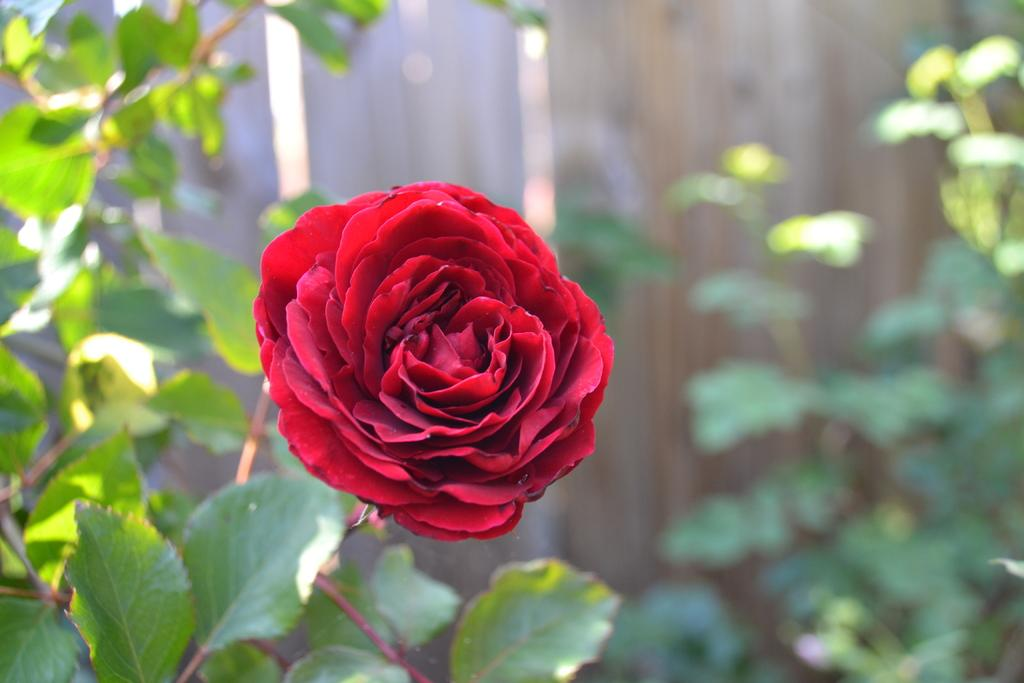What type of living organism can be seen in the image? There is a flower in the image. Are there any other plants visible in the image? Yes, there are plants in the image. Can you describe the background of the image? The background of the image is blurred. What type of linen can be seen draped over the trees in the image? There is no linen or trees present in the image; it only features a flower and plants. How many ducks are visible in the image? There are no ducks present in the image. 